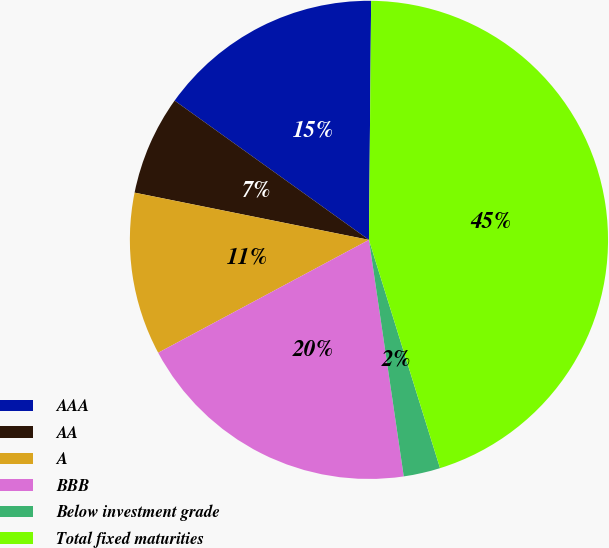<chart> <loc_0><loc_0><loc_500><loc_500><pie_chart><fcel>AAA<fcel>AA<fcel>A<fcel>BBB<fcel>Below investment grade<fcel>Total fixed maturities<nl><fcel>15.25%<fcel>6.73%<fcel>10.99%<fcel>19.5%<fcel>2.48%<fcel>45.05%<nl></chart> 